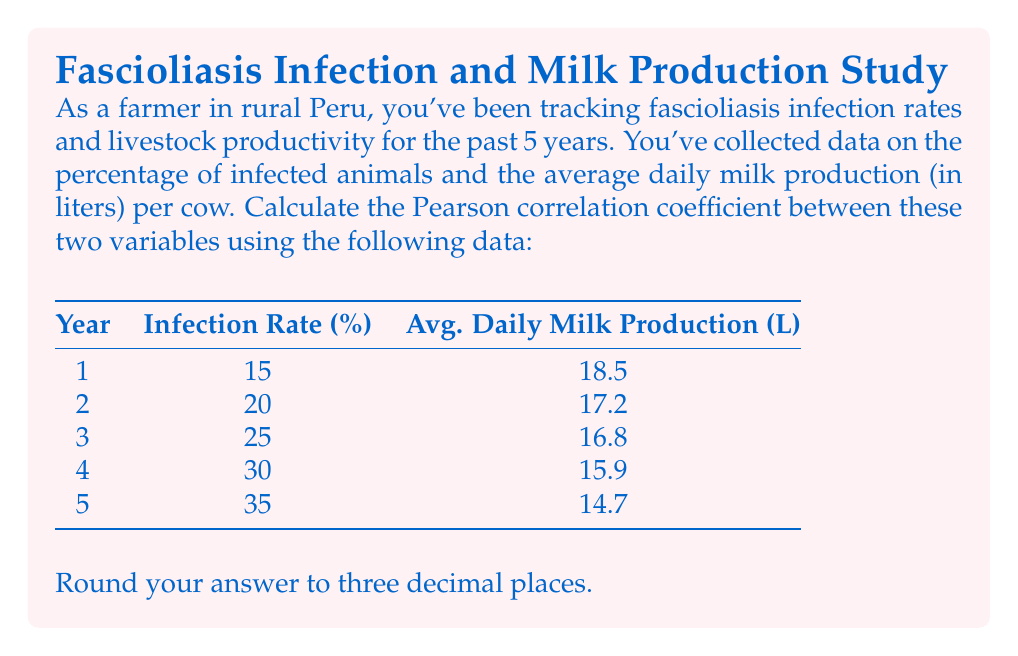Can you solve this math problem? To calculate the Pearson correlation coefficient (r) between the infection rate (x) and average daily milk production (y), we'll use the formula:

$$ r = \frac{\sum_{i=1}^{n} (x_i - \bar{x})(y_i - \bar{y})}{\sqrt{\sum_{i=1}^{n} (x_i - \bar{x})^2 \sum_{i=1}^{n} (y_i - \bar{y})^2}} $$

Step 1: Calculate the means $\bar{x}$ and $\bar{y}$
$\bar{x} = \frac{15 + 20 + 25 + 30 + 35}{5} = 25$
$\bar{y} = \frac{18.5 + 17.2 + 16.8 + 15.9 + 14.7}{5} = 16.62$

Step 2: Calculate $(x_i - \bar{x})$, $(y_i - \bar{y})$, $(x_i - \bar{x})^2$, $(y_i - \bar{y})^2$, and $(x_i - \bar{x})(y_i - \bar{y})$ for each data point.

Step 3: Sum up the values calculated in Step 2:
$\sum (x_i - \bar{x})(y_i - \bar{y}) = 15.22$
$\sum (x_i - \bar{x})^2 = 250$
$\sum (y_i - \bar{y})^2 = 7.068$

Step 4: Apply the formula:

$$ r = \frac{15.22}{\sqrt{250 \times 7.068}} = \frac{15.22}{42.0476} = -0.9614 $$

Step 5: Round to three decimal places: -0.961
Answer: -0.961 